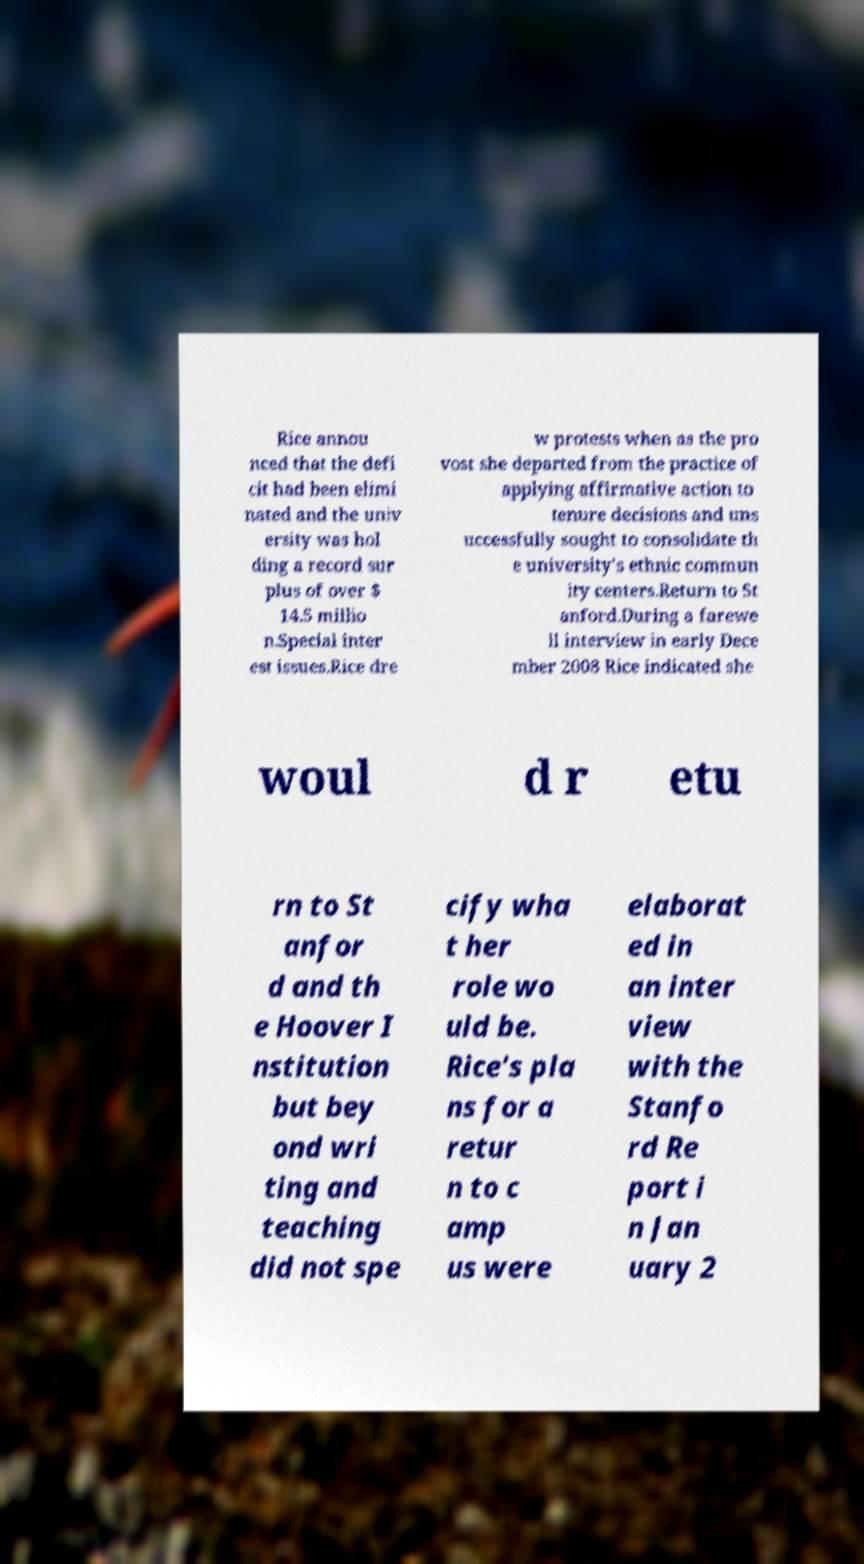Can you accurately transcribe the text from the provided image for me? Rice annou nced that the defi cit had been elimi nated and the univ ersity was hol ding a record sur plus of over $ 14.5 millio n.Special inter est issues.Rice dre w protests when as the pro vost she departed from the practice of applying affirmative action to tenure decisions and uns uccessfully sought to consolidate th e university's ethnic commun ity centers.Return to St anford.During a farewe ll interview in early Dece mber 2008 Rice indicated she woul d r etu rn to St anfor d and th e Hoover I nstitution but bey ond wri ting and teaching did not spe cify wha t her role wo uld be. Rice's pla ns for a retur n to c amp us were elaborat ed in an inter view with the Stanfo rd Re port i n Jan uary 2 